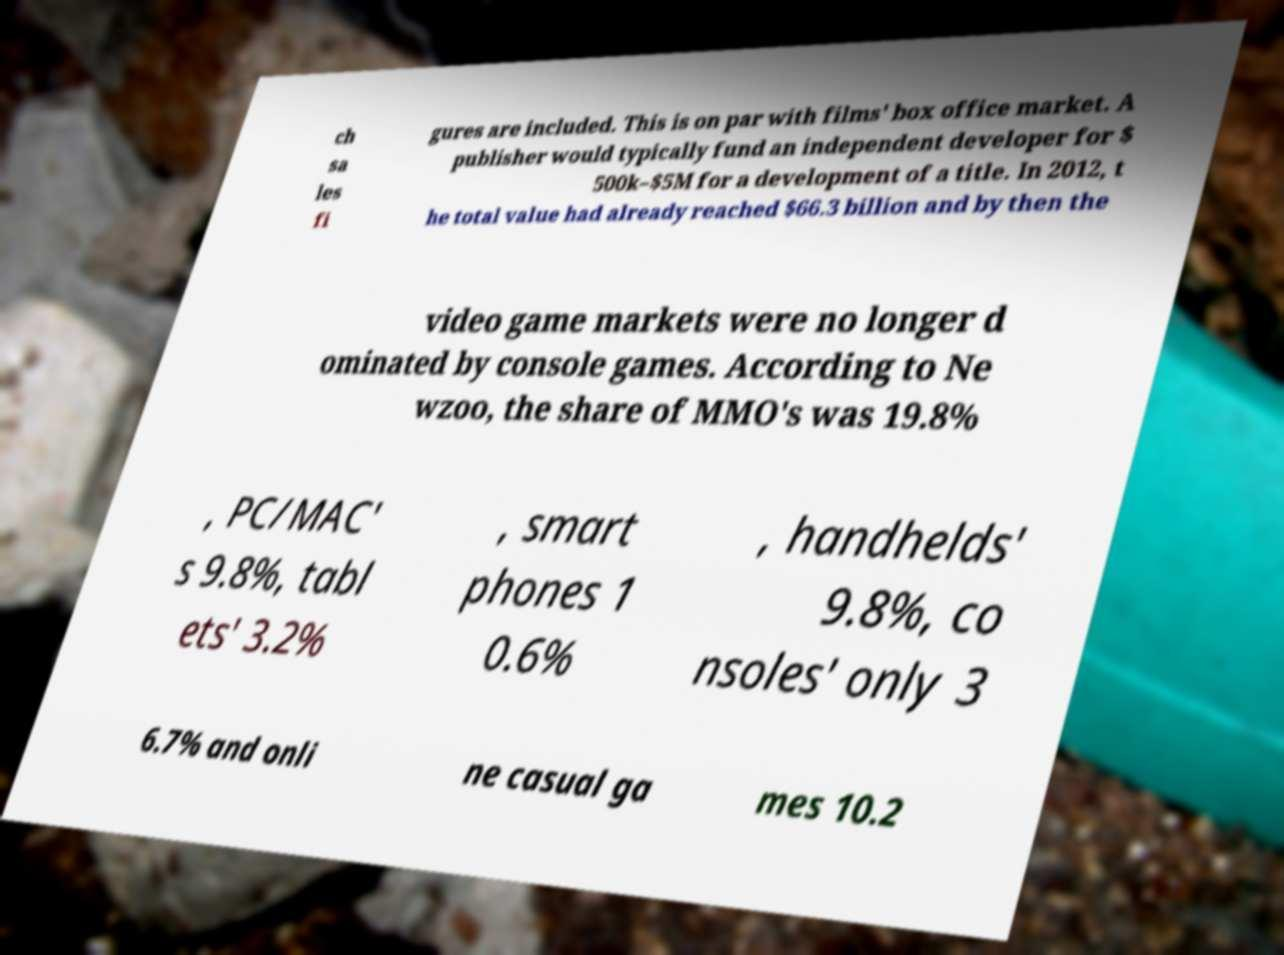Can you read and provide the text displayed in the image?This photo seems to have some interesting text. Can you extract and type it out for me? ch sa les fi gures are included. This is on par with films' box office market. A publisher would typically fund an independent developer for $ 500k–$5M for a development of a title. In 2012, t he total value had already reached $66.3 billion and by then the video game markets were no longer d ominated by console games. According to Ne wzoo, the share of MMO's was 19.8% , PC/MAC' s 9.8%, tabl ets' 3.2% , smart phones 1 0.6% , handhelds' 9.8%, co nsoles' only 3 6.7% and onli ne casual ga mes 10.2 